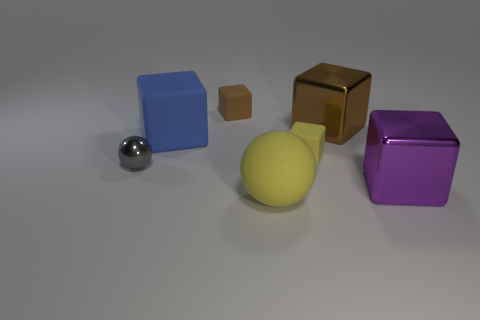What material is the ball that is on the right side of the gray ball?
Ensure brevity in your answer.  Rubber. The tiny metallic sphere has what color?
Keep it short and to the point. Gray. There is a yellow object that is on the right side of the yellow rubber sphere; is its size the same as the small gray metal object?
Provide a short and direct response. Yes. What is the material of the brown thing that is to the right of the big yellow thing to the left of the metal cube that is on the left side of the purple cube?
Ensure brevity in your answer.  Metal. Is the color of the tiny matte block that is behind the yellow cube the same as the small block in front of the big brown block?
Your answer should be very brief. No. The large object in front of the large metal block in front of the gray shiny object is made of what material?
Make the answer very short. Rubber. There is a shiny thing that is the same size as the purple block; what color is it?
Your response must be concise. Brown. There is a big yellow thing; is its shape the same as the yellow rubber object behind the large purple metallic thing?
Offer a very short reply. No. What is the shape of the tiny thing that is the same color as the big ball?
Your answer should be very brief. Cube. How many small brown cubes are in front of the thing to the right of the big shiny cube that is behind the tiny gray shiny thing?
Provide a succinct answer. 0. 